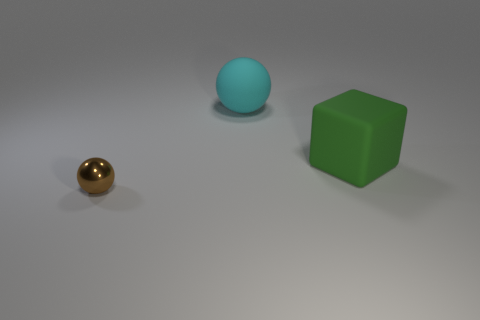Add 3 large green cubes. How many objects exist? 6 Subtract all spheres. How many objects are left? 1 Add 1 big cyan rubber balls. How many big cyan rubber balls are left? 2 Add 2 large red metallic objects. How many large red metallic objects exist? 2 Subtract 0 purple balls. How many objects are left? 3 Subtract all big matte spheres. Subtract all big yellow shiny objects. How many objects are left? 2 